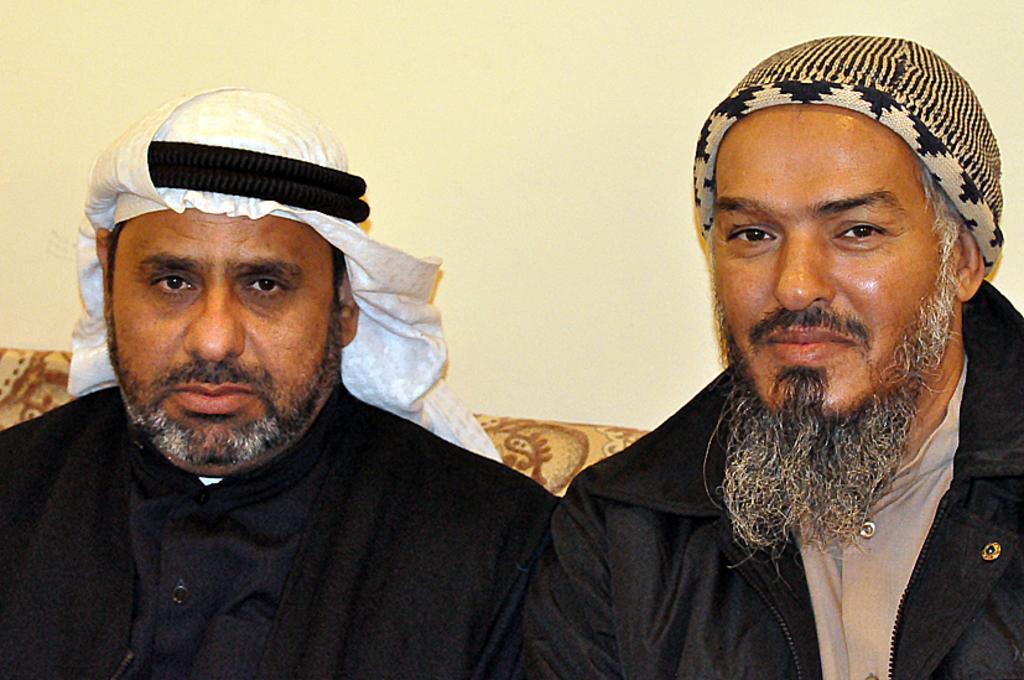Describe this image in one or two sentences. In this picture we can see two men sitting on a sofa and smiling and in the background we can see the wall. 